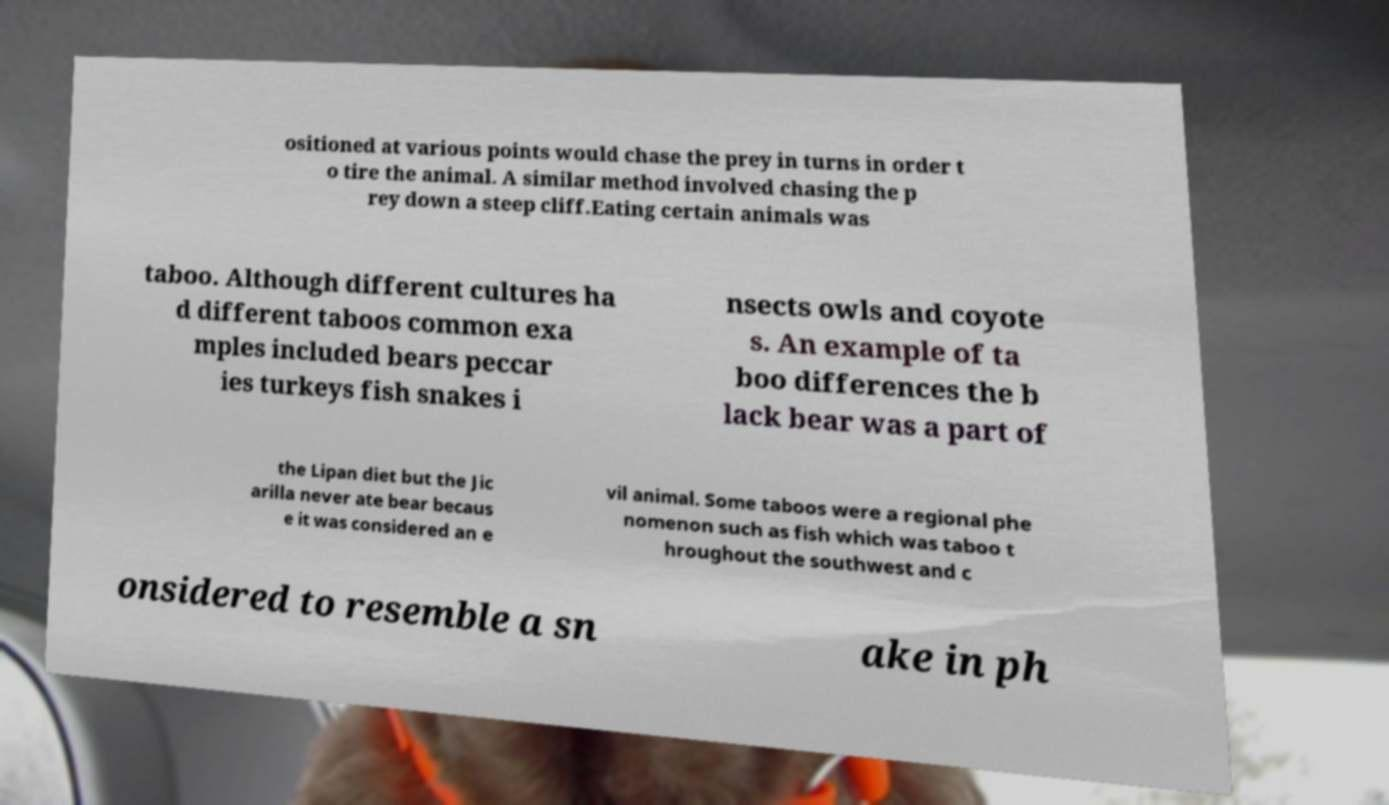I need the written content from this picture converted into text. Can you do that? ositioned at various points would chase the prey in turns in order t o tire the animal. A similar method involved chasing the p rey down a steep cliff.Eating certain animals was taboo. Although different cultures ha d different taboos common exa mples included bears peccar ies turkeys fish snakes i nsects owls and coyote s. An example of ta boo differences the b lack bear was a part of the Lipan diet but the Jic arilla never ate bear becaus e it was considered an e vil animal. Some taboos were a regional phe nomenon such as fish which was taboo t hroughout the southwest and c onsidered to resemble a sn ake in ph 